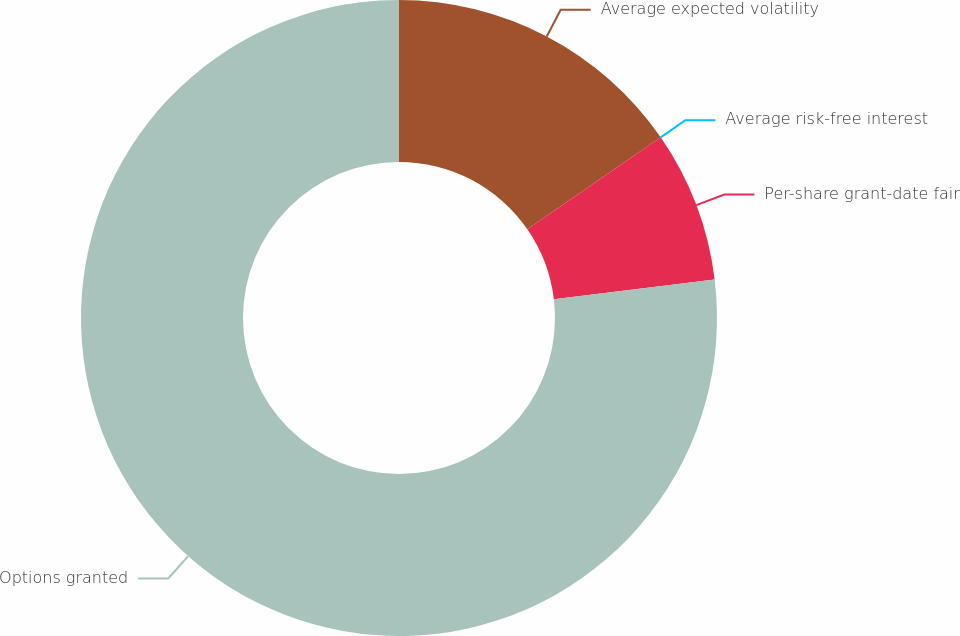Convert chart to OTSL. <chart><loc_0><loc_0><loc_500><loc_500><pie_chart><fcel>Average expected volatility<fcel>Average risk-free interest<fcel>Per-share grant-date fair<fcel>Options granted<nl><fcel>15.38%<fcel>0.0%<fcel>7.69%<fcel>76.92%<nl></chart> 